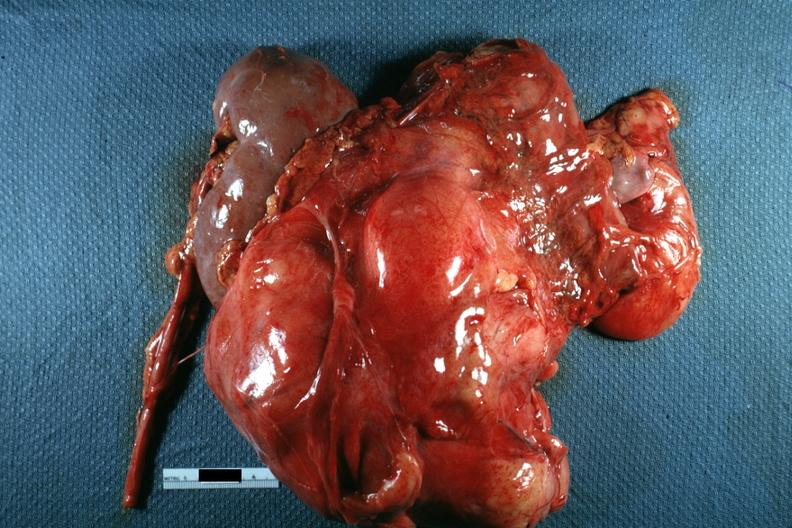s abdomen present?
Answer the question using a single word or phrase. Yes 